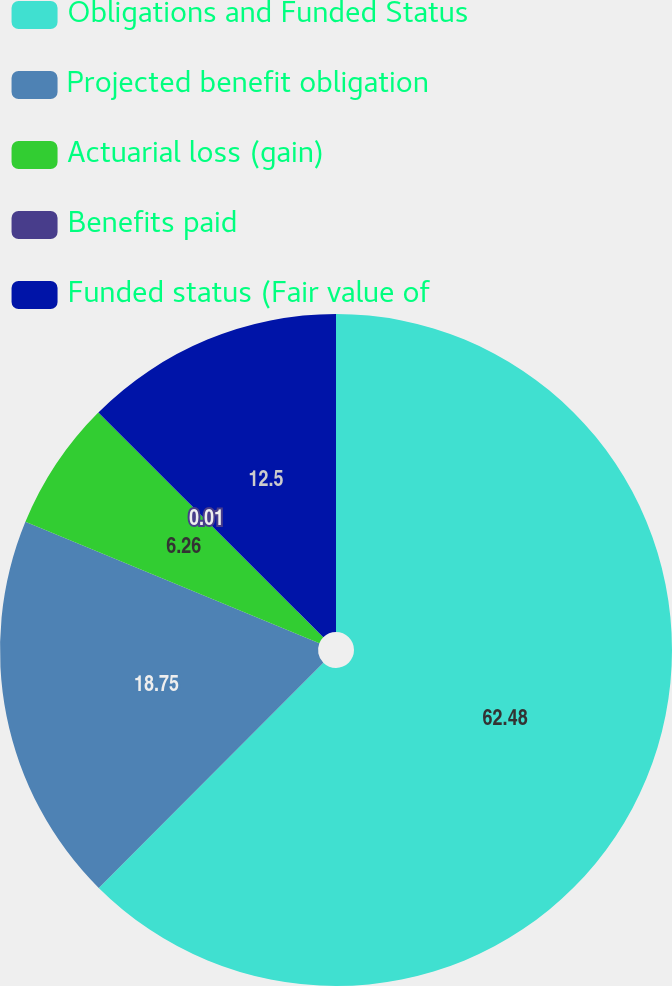<chart> <loc_0><loc_0><loc_500><loc_500><pie_chart><fcel>Obligations and Funded Status<fcel>Projected benefit obligation<fcel>Actuarial loss (gain)<fcel>Benefits paid<fcel>Funded status (Fair value of<nl><fcel>62.47%<fcel>18.75%<fcel>6.26%<fcel>0.01%<fcel>12.5%<nl></chart> 